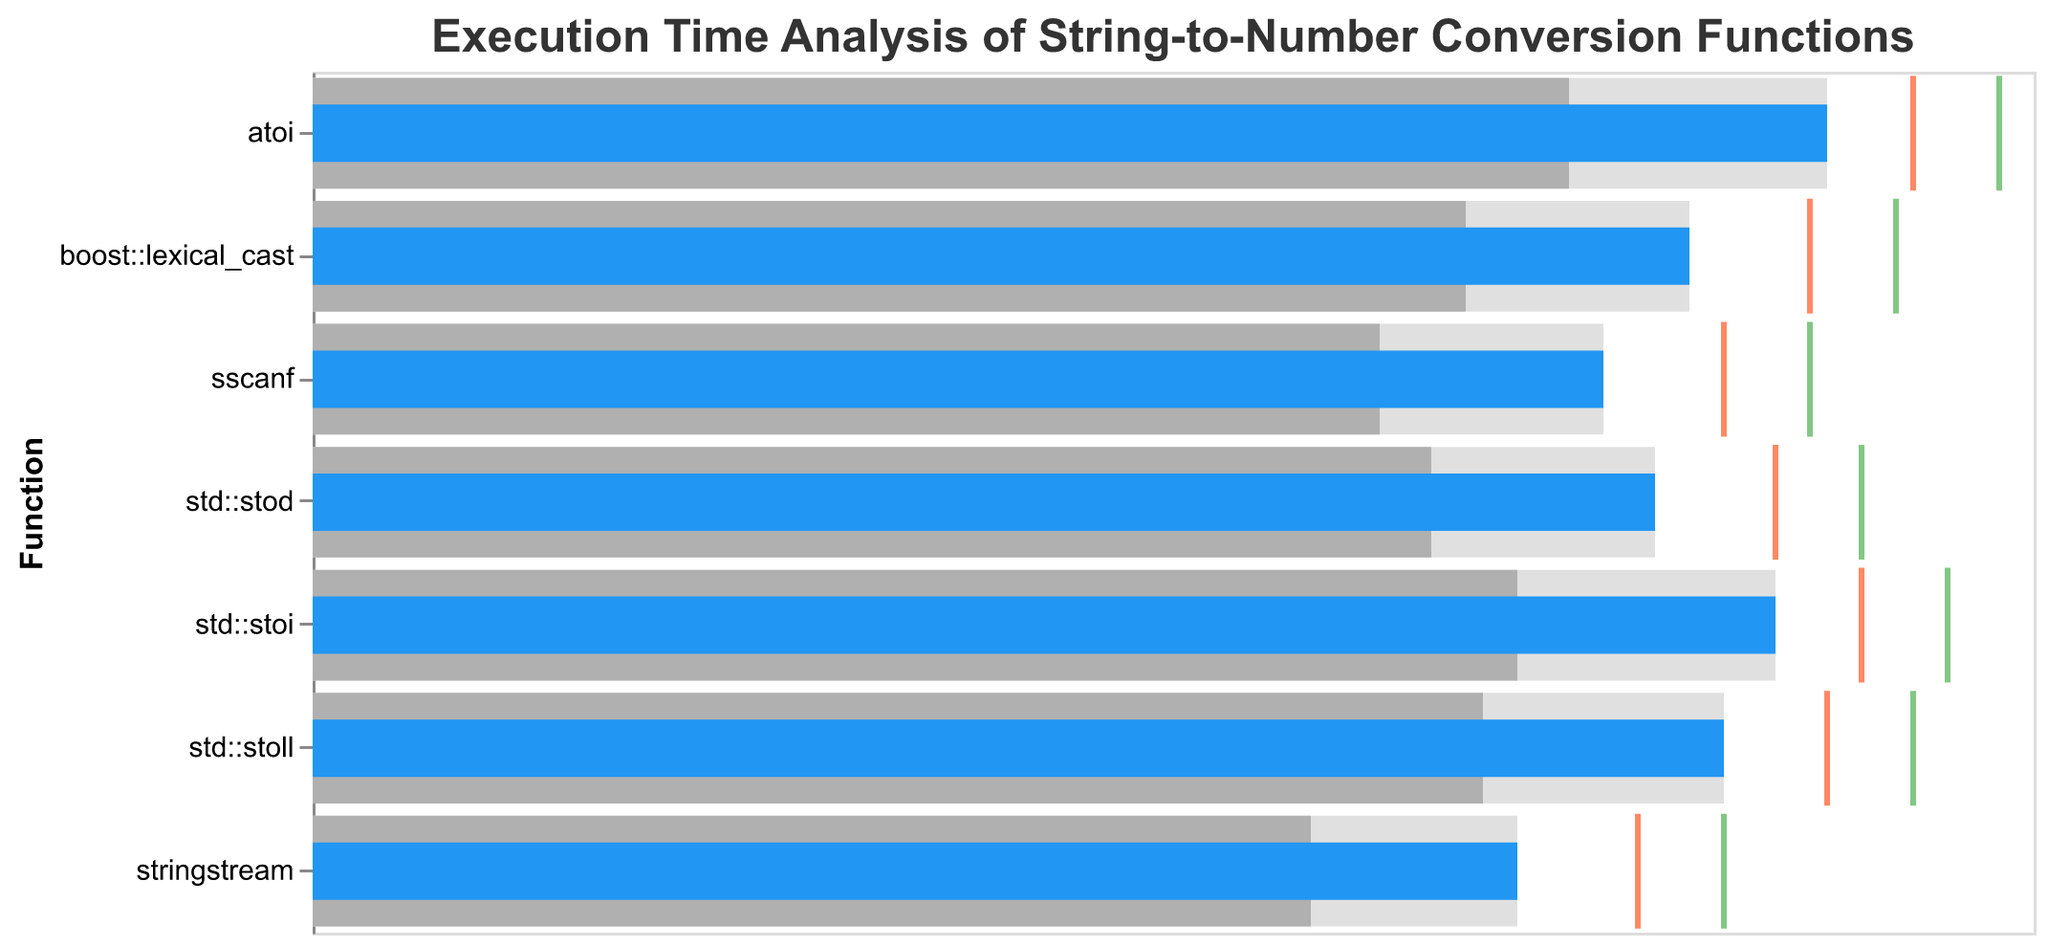What's the title of the figure? The title is displayed at the top of the figure and indicates what the chart is about. The text reads "Execution Time Analysis of String-to-Number Conversion Functions."
Answer: Execution Time Analysis of String-to-Number Conversion Functions How many functions are analyzed in the figure? Each function is represented as a separate bar in the bullet chart. By counting the bars, we see that there are 7 functions listed.
Answer: 7 Which function has the highest performance score? By comparing the performance bars for each function, the function with the longest bar is identified as having the highest score. That function is "atoi," with a performance score of 88.
Answer: atoi What is the comparative score for `std::stoll`? The comparative score is represented by a tick mark (orange) for each function. For `std::stoll`, this mark is at 88.
Answer: 88 What is the target score for `stringstream`? The target score is shown using a green tick mark. For `stringstream`, this mark is at 82.
Answer: 82 Which function has the largest gap between its performance score and its target score? To find this, we subtract the performance score from the target score for each function. The function `atoi` has a performance score of 88 and a target of 98, resulting in a gap of 10. The other functions have smaller gaps.
Answer: atoi Which function falls below its second range (lighter gray bar)? By comparing the performance score to the second range (lighter gray bar) on each function, we identify that `stringstream` (with a performance of 70 and range2 value of 58) actually falls within its second range. No function falls below its second range in this analysis.
Answer: None Which functions have their comparative scores below their target scores? Comparative scores (denoted by orange ticks) below the target scores (denoted by green ticks) are identified for each function. These functions are `std::stoi`, `std::stoll`, `std::stod`, `boost::lexical_cast`, `atoi`, `sscanf`, and `stringstream`. All functions have their comparative scores below their target scores.
Answer: All functions Is `sscanf` performing above its third range? The third range (darkest gray bar) for `sscanf` ends at 75. By comparing this with the performance score of `sscanf`, which is also 75, it is determined that it is not performing above its third range.
Answer: No 